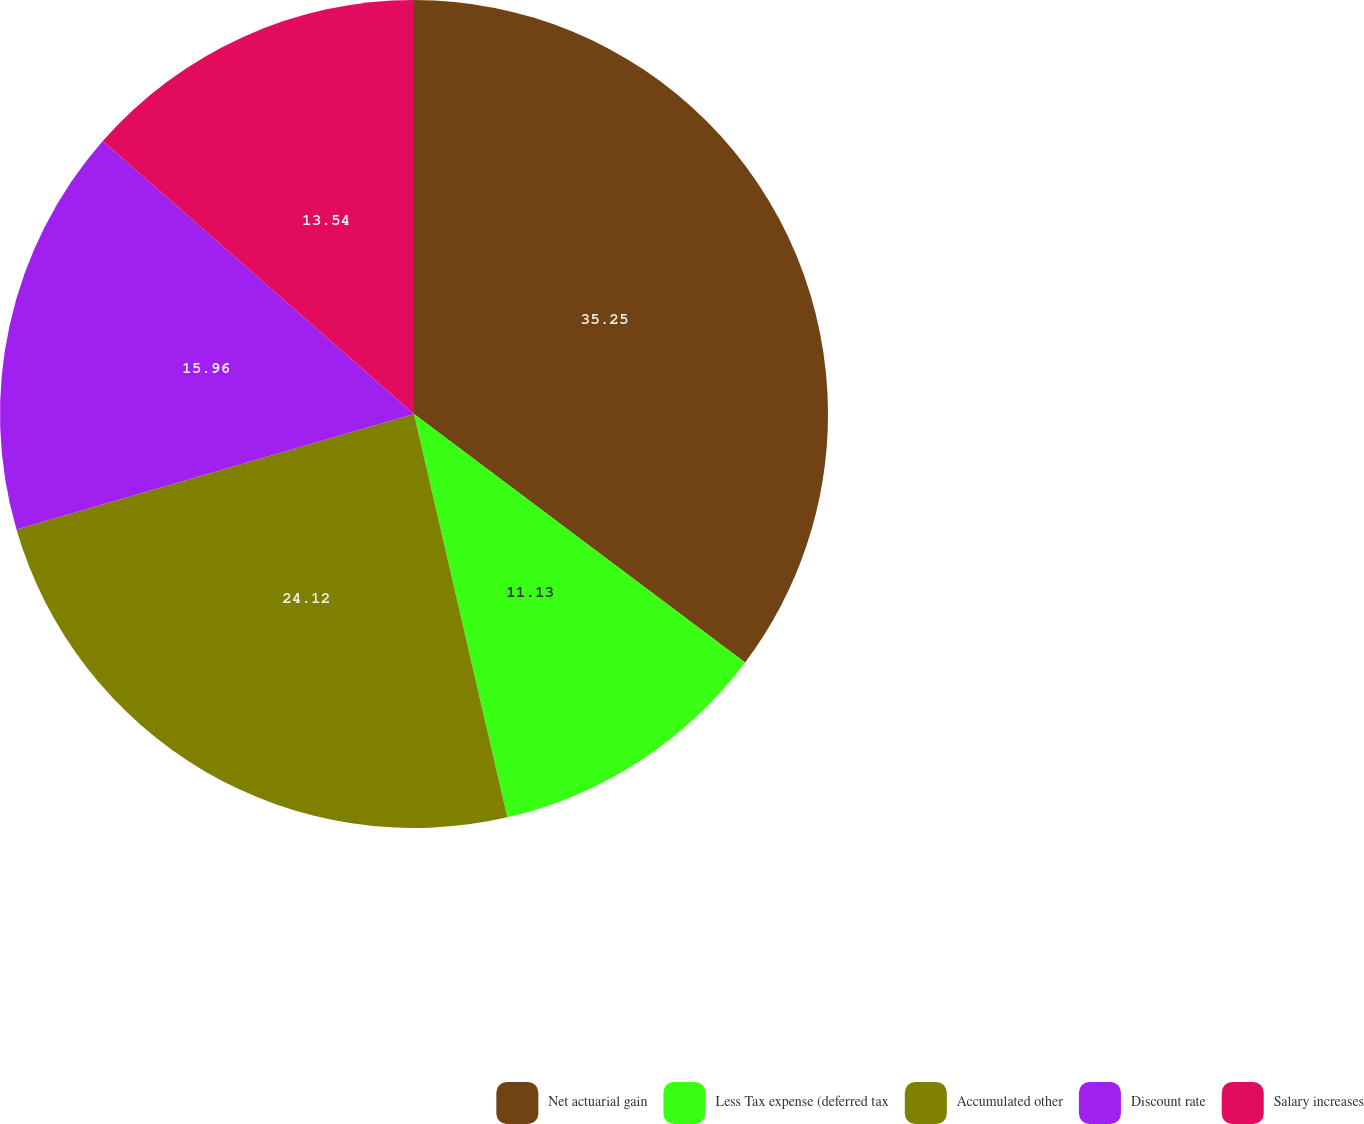Convert chart to OTSL. <chart><loc_0><loc_0><loc_500><loc_500><pie_chart><fcel>Net actuarial gain<fcel>Less Tax expense (deferred tax<fcel>Accumulated other<fcel>Discount rate<fcel>Salary increases<nl><fcel>35.25%<fcel>11.13%<fcel>24.12%<fcel>15.96%<fcel>13.54%<nl></chart> 